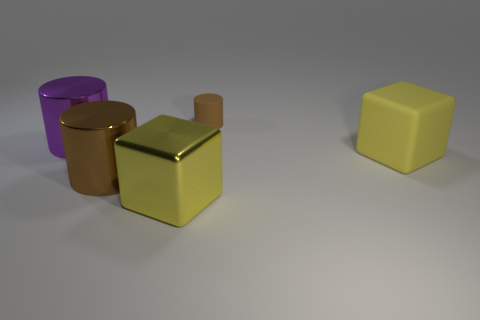Subtract all tiny rubber cylinders. How many cylinders are left? 2 Add 4 small brown objects. How many objects exist? 9 Subtract all purple cylinders. How many cylinders are left? 2 Subtract 2 cylinders. How many cylinders are left? 1 Subtract 1 purple cylinders. How many objects are left? 4 Subtract all cubes. How many objects are left? 3 Subtract all blue cylinders. Subtract all green blocks. How many cylinders are left? 3 Subtract all red cubes. How many purple cylinders are left? 1 Subtract all metal objects. Subtract all large matte spheres. How many objects are left? 2 Add 1 big matte cubes. How many big matte cubes are left? 2 